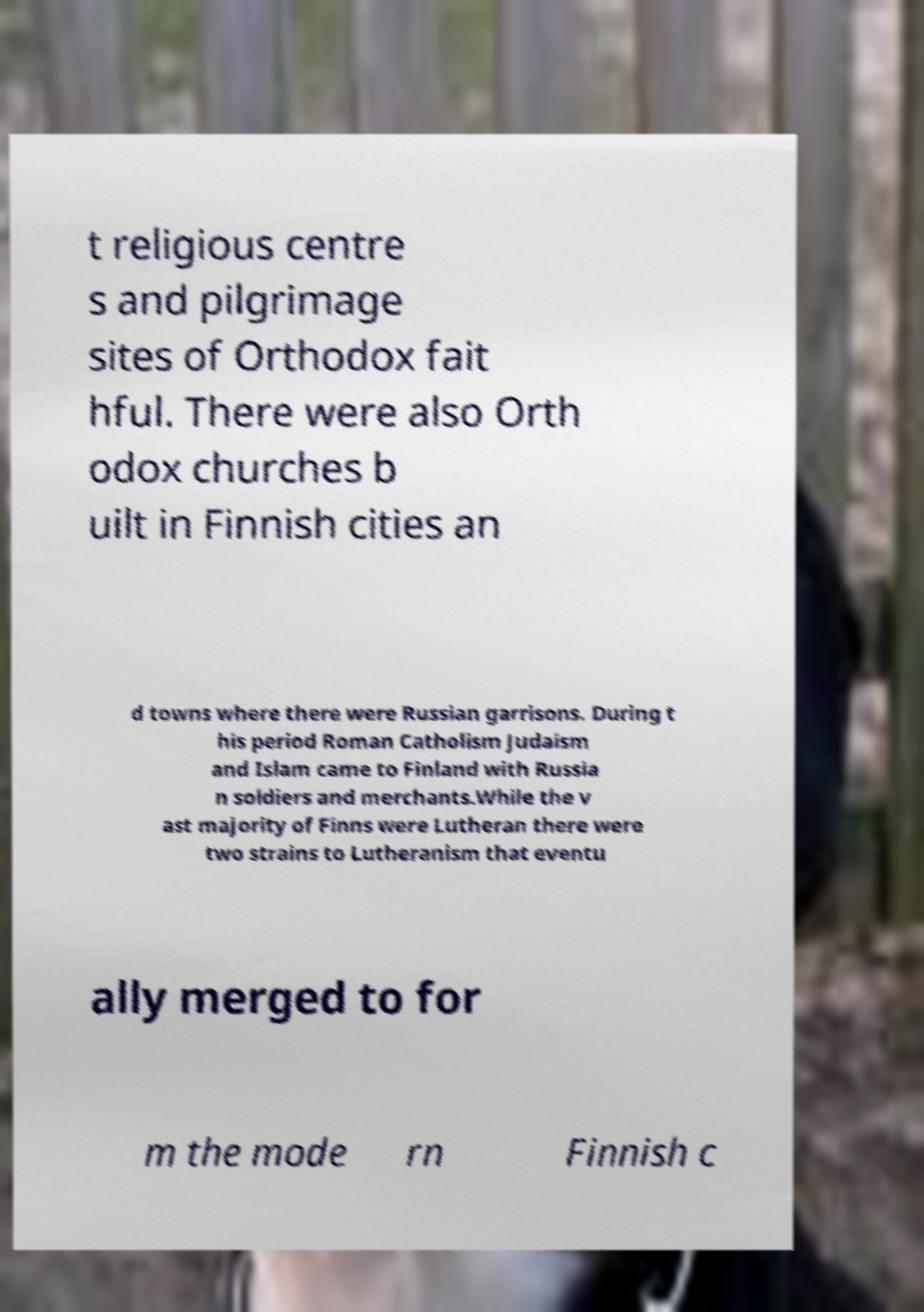Can you accurately transcribe the text from the provided image for me? t religious centre s and pilgrimage sites of Orthodox fait hful. There were also Orth odox churches b uilt in Finnish cities an d towns where there were Russian garrisons. During t his period Roman Catholism Judaism and Islam came to Finland with Russia n soldiers and merchants.While the v ast majority of Finns were Lutheran there were two strains to Lutheranism that eventu ally merged to for m the mode rn Finnish c 